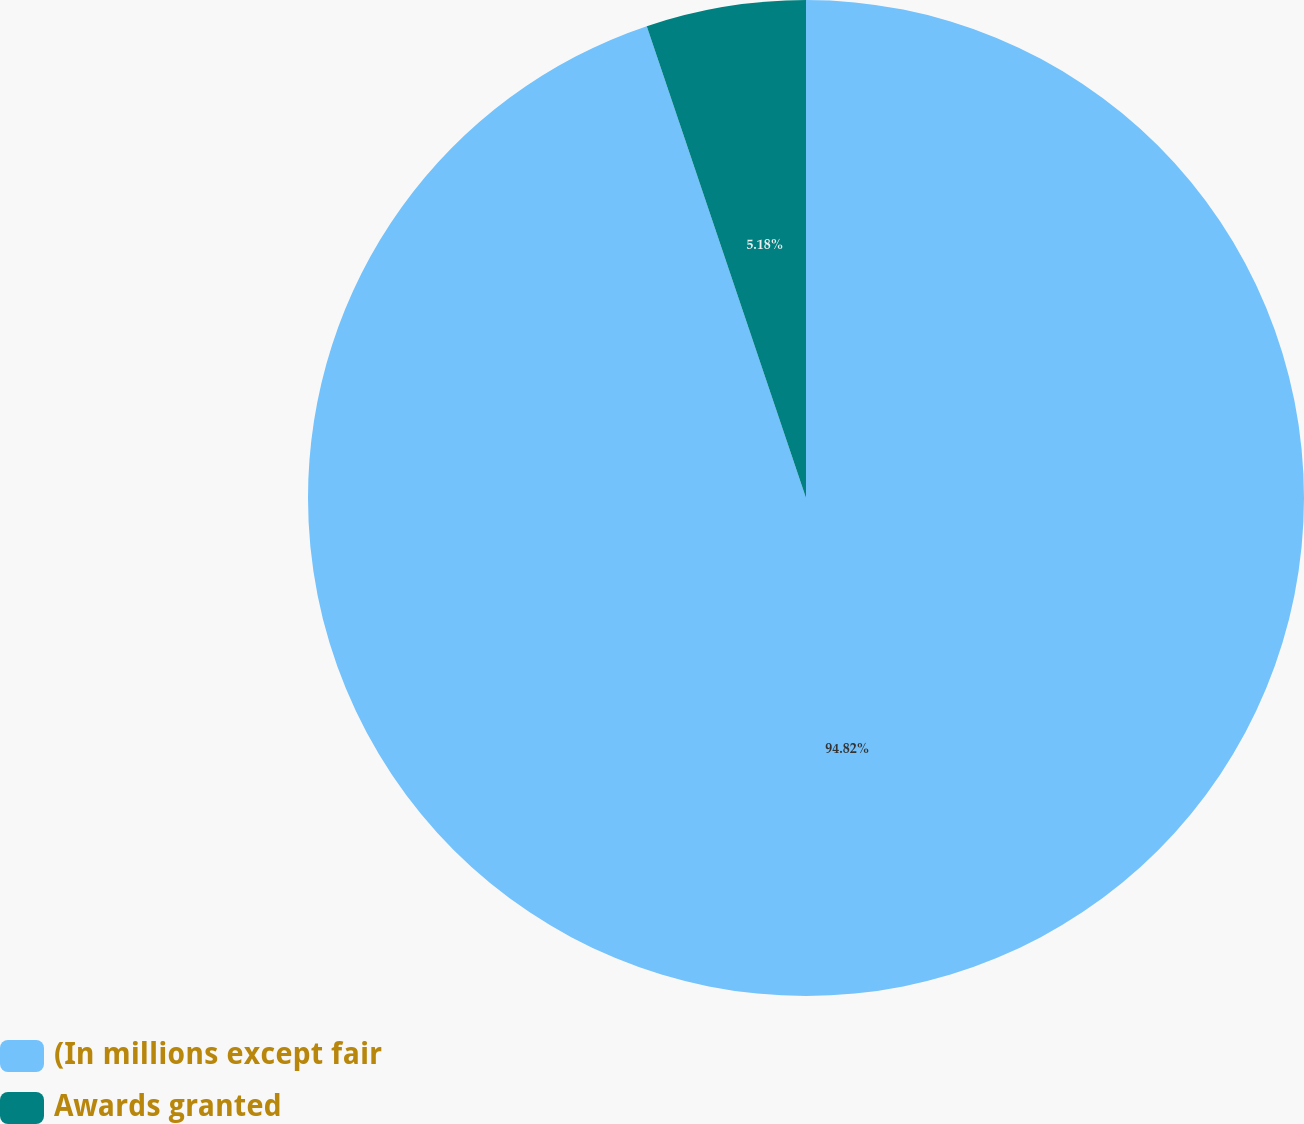Convert chart to OTSL. <chart><loc_0><loc_0><loc_500><loc_500><pie_chart><fcel>(In millions except fair<fcel>Awards granted<nl><fcel>94.82%<fcel>5.18%<nl></chart> 